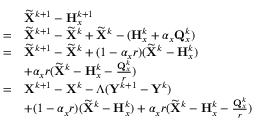Convert formula to latex. <formula><loc_0><loc_0><loc_500><loc_500>\begin{array} { r l } & { \widetilde { X } ^ { k + 1 } - { H } _ { x } ^ { k + 1 } } \\ { = } & { \widetilde { X } ^ { k + 1 } - \widetilde { X } ^ { k } + \widetilde { X } ^ { k } - ( { H } _ { x } ^ { k } + \alpha _ { x } { Q } _ { x } ^ { k } ) } \\ { = } & { \widetilde { X } ^ { k + 1 } - \widetilde { X } ^ { k } + ( 1 - \alpha _ { x } r ) ( \widetilde { X } ^ { k } - { H } _ { x } ^ { k } ) } \\ & { + \alpha _ { x } r ( \widetilde { X } ^ { k } - { H } _ { x } ^ { k } - \frac { { Q } _ { x } ^ { k } } { r } ) } \\ { = } & { { X } ^ { k + 1 } - { X } ^ { k } - \Lambda ( { Y } ^ { k + 1 } - { Y } ^ { k } ) } \\ & { + ( 1 - \alpha _ { x } r ) ( \widetilde { X } ^ { k } - { H } _ { x } ^ { k } ) + \alpha _ { x } r ( \widetilde { X } ^ { k } - { H } _ { x } ^ { k } - \frac { { Q } _ { x } ^ { k } } { r } ) } \end{array}</formula> 